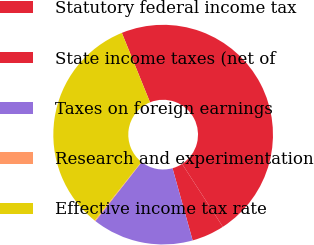Convert chart to OTSL. <chart><loc_0><loc_0><loc_500><loc_500><pie_chart><fcel>Statutory federal income tax<fcel>State income taxes (net of<fcel>Taxes on foreign earnings<fcel>Research and experimentation<fcel>Effective income tax rate<nl><fcel>46.99%<fcel>4.82%<fcel>14.9%<fcel>0.13%<fcel>33.16%<nl></chart> 